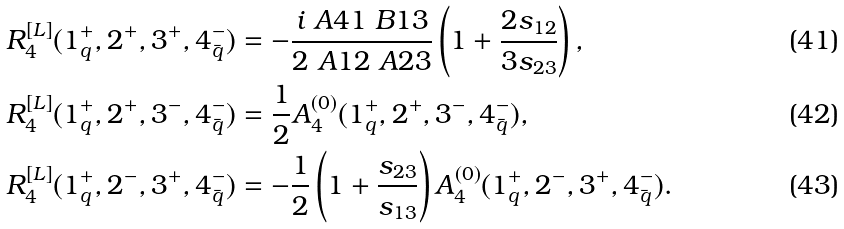Convert formula to latex. <formula><loc_0><loc_0><loc_500><loc_500>R _ { 4 } ^ { [ L ] } ( 1 _ { q } ^ { + } , 2 ^ { + } , 3 ^ { + } , 4 _ { \bar { q } } ^ { - } ) & = - \frac { i \ A 4 1 \ B 1 3 } { 2 \ A 1 2 \ A 2 3 } \left ( 1 + \frac { 2 s _ { 1 2 } } { 3 s _ { 2 3 } } \right ) , \\ R _ { 4 } ^ { [ L ] } ( 1 _ { q } ^ { + } , 2 ^ { + } , 3 ^ { - } , 4 _ { \bar { q } } ^ { - } ) & = \frac { 1 } { 2 } A _ { 4 } ^ { ( 0 ) } ( 1 _ { q } ^ { + } , 2 ^ { + } , 3 ^ { - } , 4 _ { \bar { q } } ^ { - } ) , \\ R _ { 4 } ^ { [ L ] } ( 1 _ { q } ^ { + } , 2 ^ { - } , 3 ^ { + } , 4 _ { \bar { q } } ^ { - } ) & = - \frac { 1 } { 2 } \left ( 1 + \frac { s _ { 2 3 } } { s _ { 1 3 } } \right ) A _ { 4 } ^ { ( 0 ) } ( 1 _ { q } ^ { + } , 2 ^ { - } , 3 ^ { + } , 4 _ { \bar { q } } ^ { - } ) .</formula> 